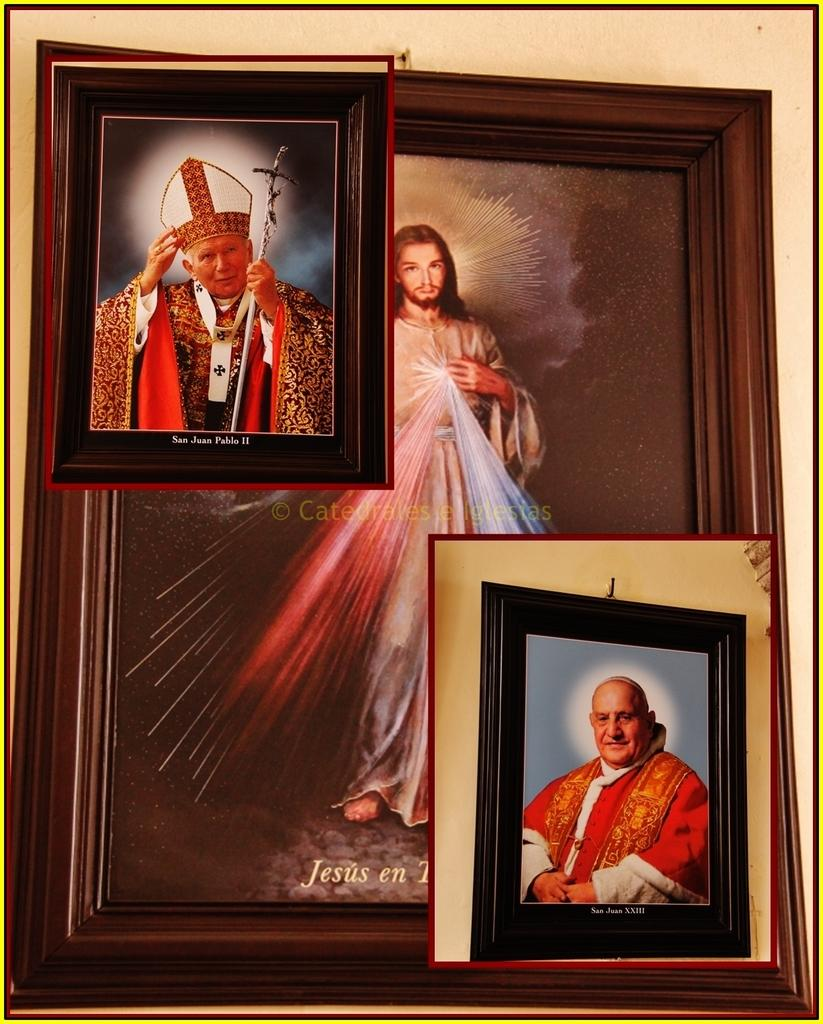<image>
Share a concise interpretation of the image provided. A picture San Juan Pablo II is sitting on top of a picture of Jesus 